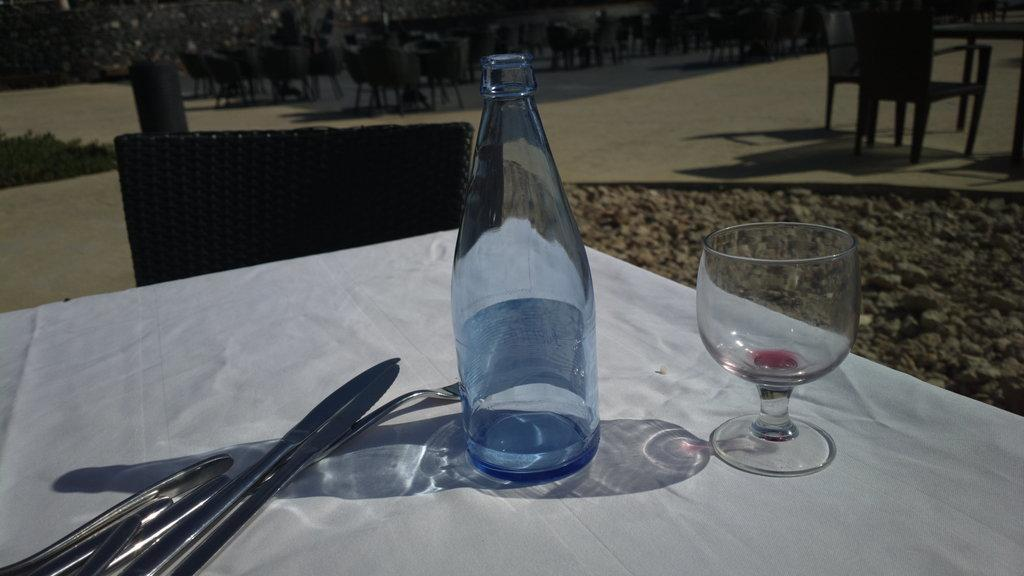What is the main piece of furniture in the image? There is a table in the image. What is covering the table? There is a white sheet on the table. What utensils can be seen on the table? Knives and forks are present on the table. What type of container is on the table? There is a bottle on the table. What type of glassware is on the table? There is a glass on the table. What type of seating is visible in the image? There are chairs in the image. How many chairs are visible in the background? In the background, there are many chairs. What type of natural scenery is visible in the background? Trees are visible in the background. What type of pet is sitting on the table in the image? There is no pet present on the table in the image. What type of doll is sitting on the chair in the image? There is no doll present in the image. 